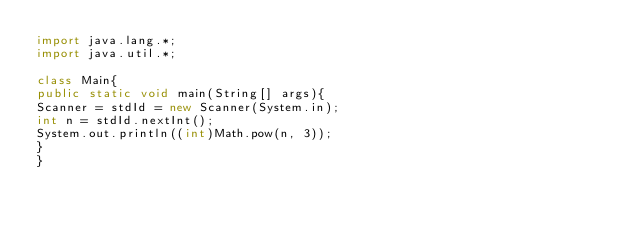<code> <loc_0><loc_0><loc_500><loc_500><_Java_>import java.lang.*;
import java.util.*;

class Main{
public static void main(String[] args){
Scanner = stdId = new Scanner(System.in);
int n = stdId.nextInt();
System.out.println((int)Math.pow(n, 3));
}
}</code> 